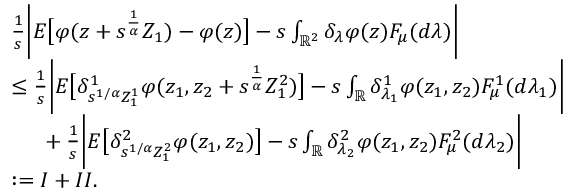<formula> <loc_0><loc_0><loc_500><loc_500>\begin{array} { r l } & { \frac { 1 } { s } \left | E \left [ \varphi ( z + s ^ { \frac { 1 } { \alpha } } Z _ { 1 } ) - \varphi ( z ) \right ] - s \int _ { \mathbb { R } ^ { 2 } } \delta _ { \lambda } \varphi ( z ) F _ { \mu } ( d \lambda ) \right | } \\ & { \leq \frac { 1 } { s } \left | E \left [ \delta _ { s ^ { 1 / \alpha } Z _ { 1 } ^ { 1 } } ^ { 1 } \varphi ( z _ { 1 } , z _ { 2 } + s ^ { \frac { 1 } { \alpha } } Z _ { 1 } ^ { 2 } ) \right ] - s \int _ { \mathbb { R } } \delta _ { \lambda _ { 1 } } ^ { 1 } \varphi ( z _ { 1 } , z _ { 2 } ) F _ { \mu } ^ { 1 } ( d \lambda _ { 1 } ) \right | } \\ & { \ \ + \frac { 1 } { s } \left | E \left [ \delta _ { s ^ { 1 / \alpha } Z _ { 1 } ^ { 2 } } ^ { 2 } \varphi ( z _ { 1 } , z _ { 2 } ) \right ] - s \int _ { \mathbb { R } } \delta _ { \lambda _ { 2 } } ^ { 2 } \varphi ( z _ { 1 } , z _ { 2 } ) F _ { \mu } ^ { 2 } ( d \lambda _ { 2 } ) \right | } \\ & { \colon = I + I I . } \end{array}</formula> 